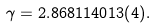<formula> <loc_0><loc_0><loc_500><loc_500>\gamma = 2 . 8 6 8 1 1 4 0 1 3 ( 4 ) .</formula> 